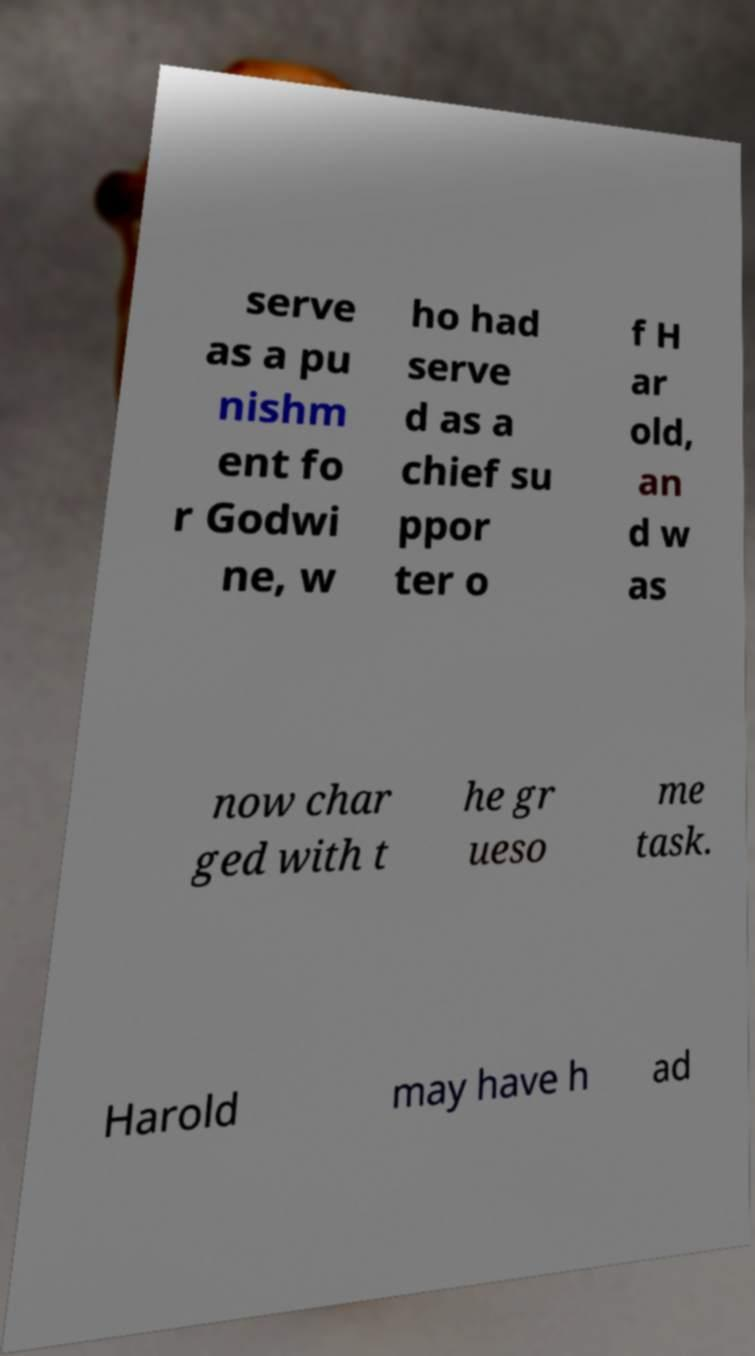Could you extract and type out the text from this image? serve as a pu nishm ent fo r Godwi ne, w ho had serve d as a chief su ppor ter o f H ar old, an d w as now char ged with t he gr ueso me task. Harold may have h ad 